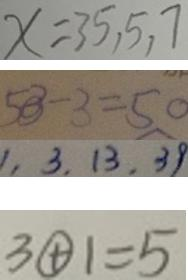Convert formula to latex. <formula><loc_0><loc_0><loc_500><loc_500>x = 3 5 , 5 , 7 
 5 3 - 3 = 5 0 
 1 , 3 , 1 3 , 3 9 
 3 \textcircled { + } 1 = 5</formula> 